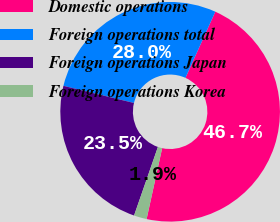<chart> <loc_0><loc_0><loc_500><loc_500><pie_chart><fcel>Domestic operations<fcel>Foreign operations total<fcel>Foreign operations Japan<fcel>Foreign operations Korea<nl><fcel>46.69%<fcel>27.95%<fcel>23.47%<fcel>1.89%<nl></chart> 